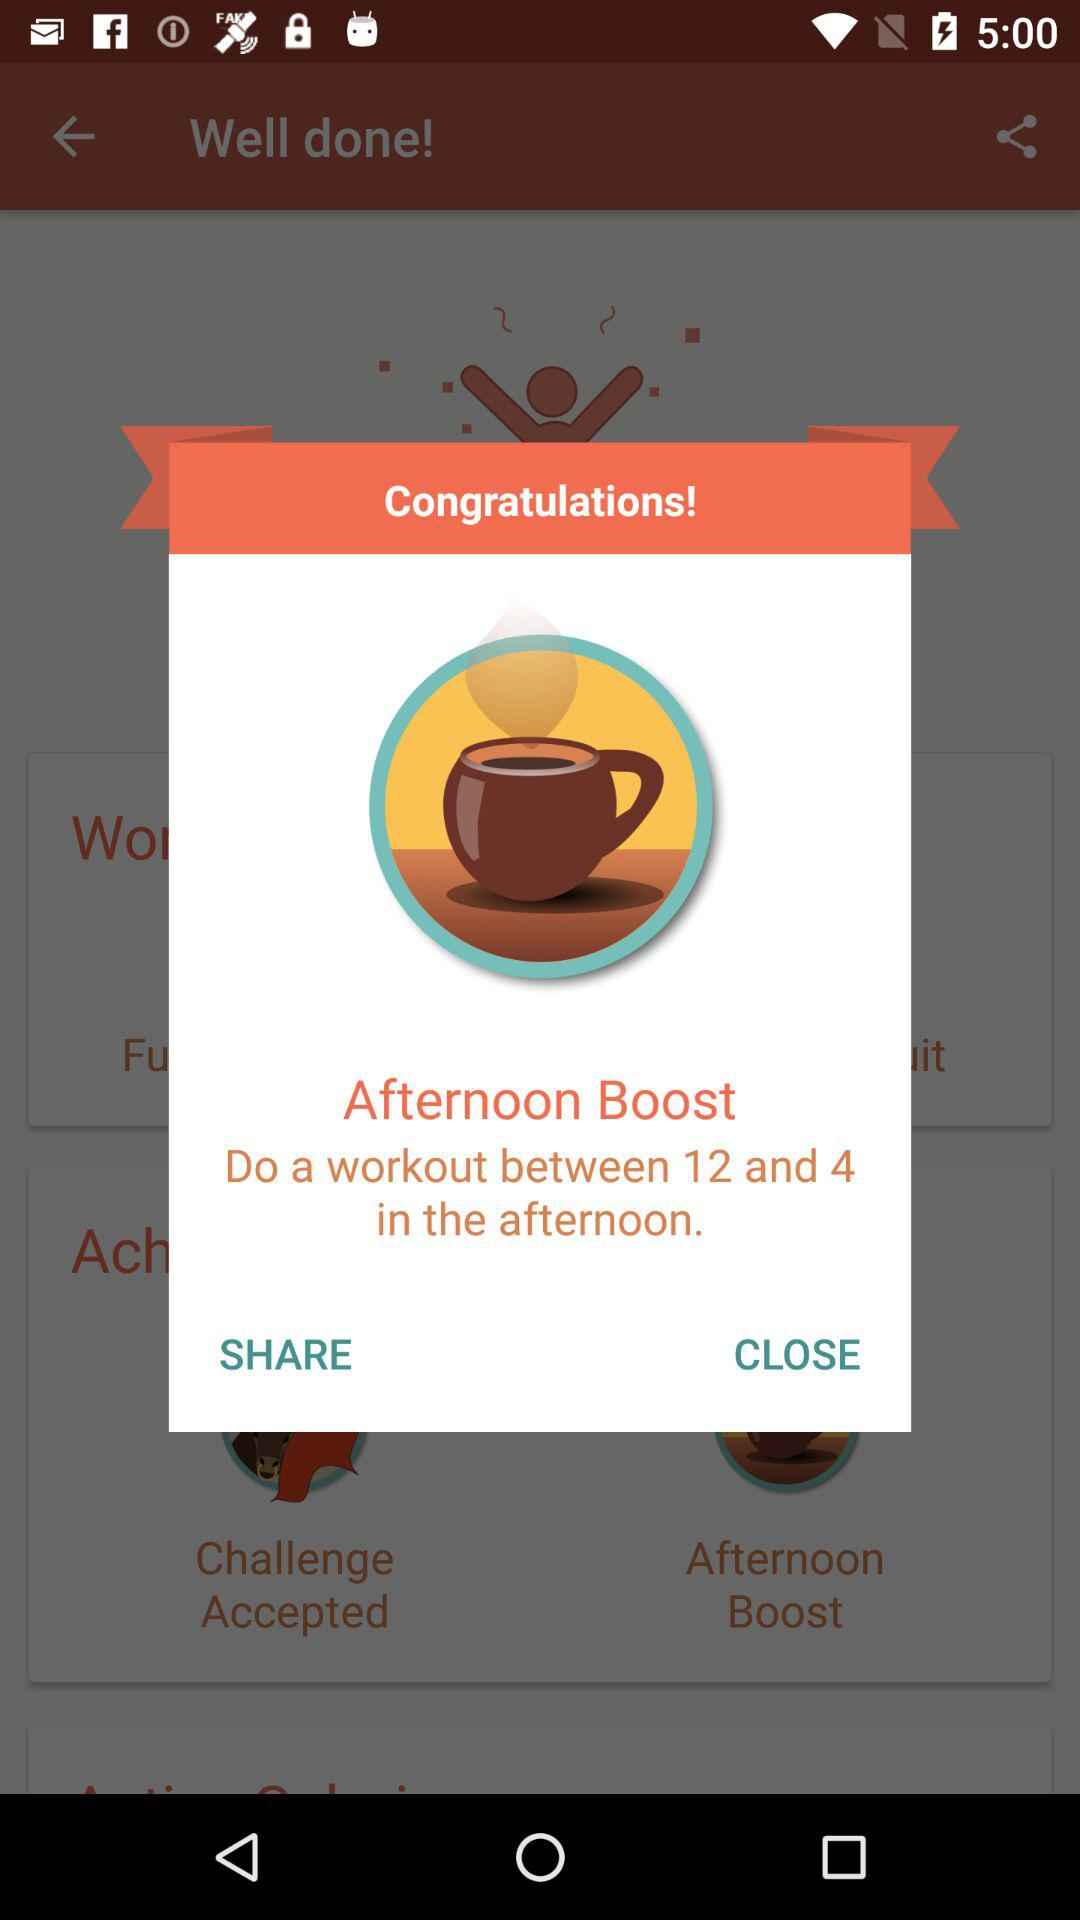What is the timing for a workout in the afternoon? The timing for a workout is between 12 and 4. 